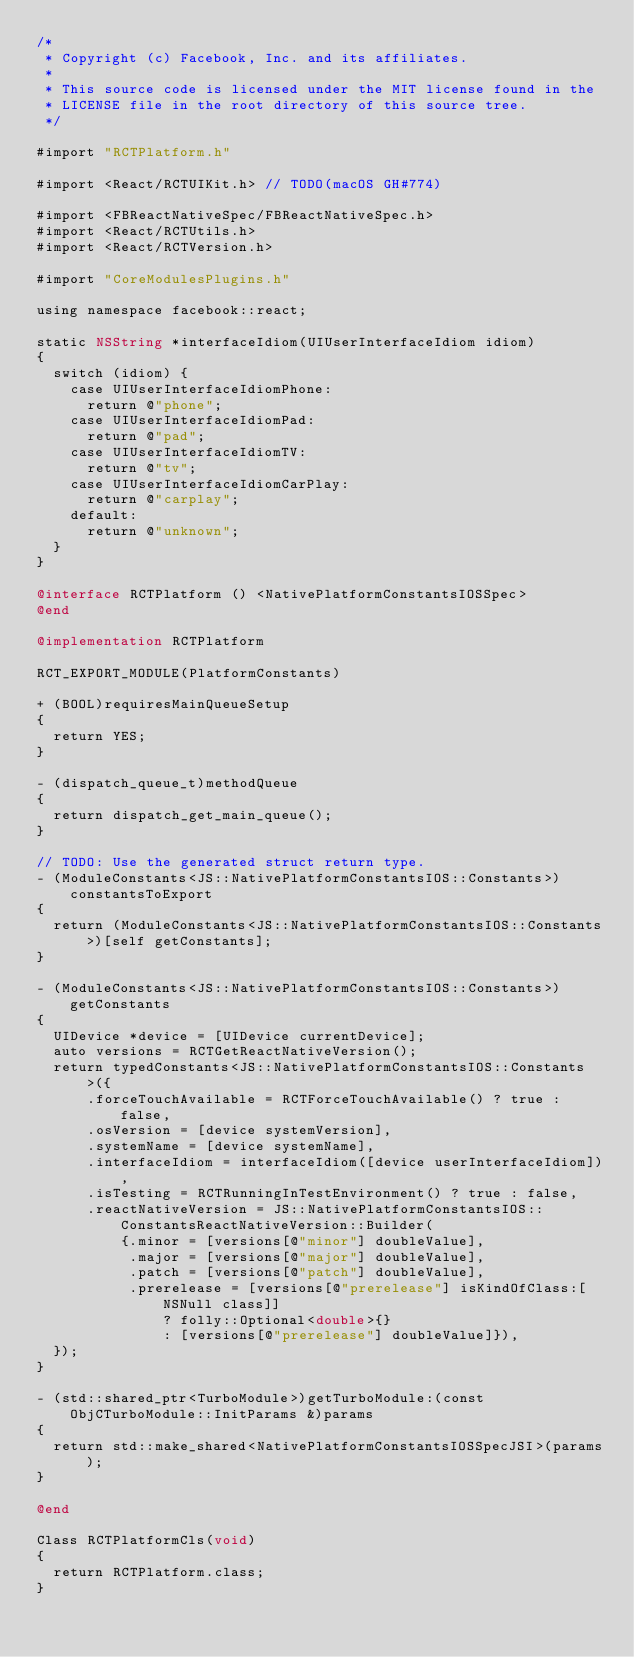<code> <loc_0><loc_0><loc_500><loc_500><_ObjectiveC_>/*
 * Copyright (c) Facebook, Inc. and its affiliates.
 *
 * This source code is licensed under the MIT license found in the
 * LICENSE file in the root directory of this source tree.
 */

#import "RCTPlatform.h"

#import <React/RCTUIKit.h> // TODO(macOS GH#774)

#import <FBReactNativeSpec/FBReactNativeSpec.h>
#import <React/RCTUtils.h>
#import <React/RCTVersion.h>

#import "CoreModulesPlugins.h"

using namespace facebook::react;

static NSString *interfaceIdiom(UIUserInterfaceIdiom idiom)
{
  switch (idiom) {
    case UIUserInterfaceIdiomPhone:
      return @"phone";
    case UIUserInterfaceIdiomPad:
      return @"pad";
    case UIUserInterfaceIdiomTV:
      return @"tv";
    case UIUserInterfaceIdiomCarPlay:
      return @"carplay";
    default:
      return @"unknown";
  }
}

@interface RCTPlatform () <NativePlatformConstantsIOSSpec>
@end

@implementation RCTPlatform

RCT_EXPORT_MODULE(PlatformConstants)

+ (BOOL)requiresMainQueueSetup
{
  return YES;
}

- (dispatch_queue_t)methodQueue
{
  return dispatch_get_main_queue();
}

// TODO: Use the generated struct return type.
- (ModuleConstants<JS::NativePlatformConstantsIOS::Constants>)constantsToExport
{
  return (ModuleConstants<JS::NativePlatformConstantsIOS::Constants>)[self getConstants];
}

- (ModuleConstants<JS::NativePlatformConstantsIOS::Constants>)getConstants
{
  UIDevice *device = [UIDevice currentDevice];
  auto versions = RCTGetReactNativeVersion();
  return typedConstants<JS::NativePlatformConstantsIOS::Constants>({
      .forceTouchAvailable = RCTForceTouchAvailable() ? true : false,
      .osVersion = [device systemVersion],
      .systemName = [device systemName],
      .interfaceIdiom = interfaceIdiom([device userInterfaceIdiom]),
      .isTesting = RCTRunningInTestEnvironment() ? true : false,
      .reactNativeVersion = JS::NativePlatformConstantsIOS::ConstantsReactNativeVersion::Builder(
          {.minor = [versions[@"minor"] doubleValue],
           .major = [versions[@"major"] doubleValue],
           .patch = [versions[@"patch"] doubleValue],
           .prerelease = [versions[@"prerelease"] isKindOfClass:[NSNull class]]
               ? folly::Optional<double>{}
               : [versions[@"prerelease"] doubleValue]}),
  });
}

- (std::shared_ptr<TurboModule>)getTurboModule:(const ObjCTurboModule::InitParams &)params
{
  return std::make_shared<NativePlatformConstantsIOSSpecJSI>(params);
}

@end

Class RCTPlatformCls(void)
{
  return RCTPlatform.class;
}
</code> 